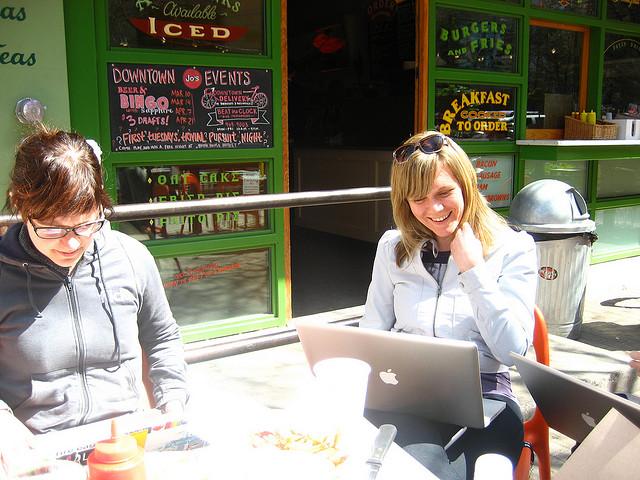Was this picture taken outside?
Answer briefly. Yes. Are both women smiling?
Keep it brief. Yes. Is the trash can made of metal?
Write a very short answer. Yes. 